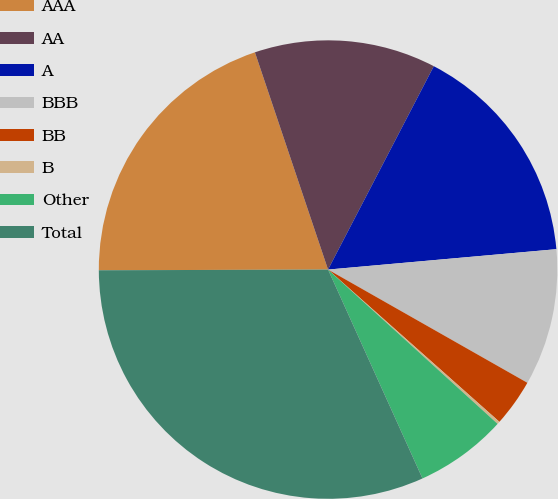Convert chart to OTSL. <chart><loc_0><loc_0><loc_500><loc_500><pie_chart><fcel>AAA<fcel>AA<fcel>A<fcel>BBB<fcel>BB<fcel>B<fcel>Other<fcel>Total<nl><fcel>19.88%<fcel>12.8%<fcel>15.95%<fcel>9.64%<fcel>3.34%<fcel>0.19%<fcel>6.49%<fcel>31.71%<nl></chart> 